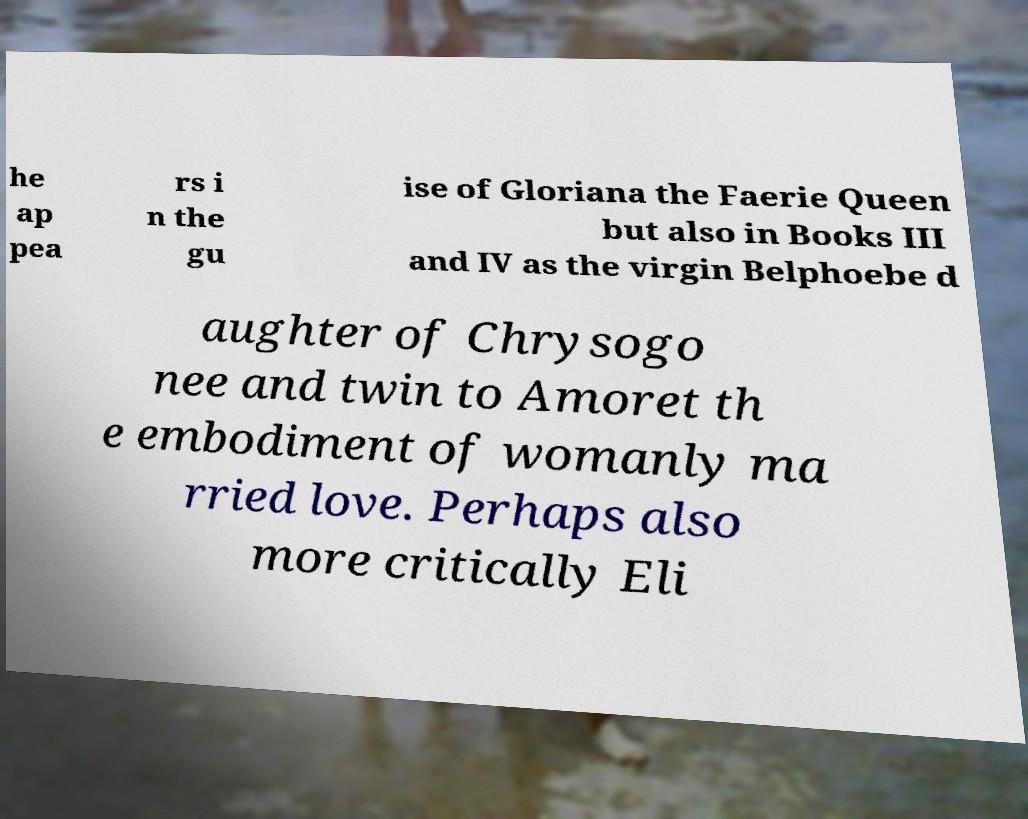Please read and relay the text visible in this image. What does it say? he ap pea rs i n the gu ise of Gloriana the Faerie Queen but also in Books III and IV as the virgin Belphoebe d aughter of Chrysogo nee and twin to Amoret th e embodiment of womanly ma rried love. Perhaps also more critically Eli 